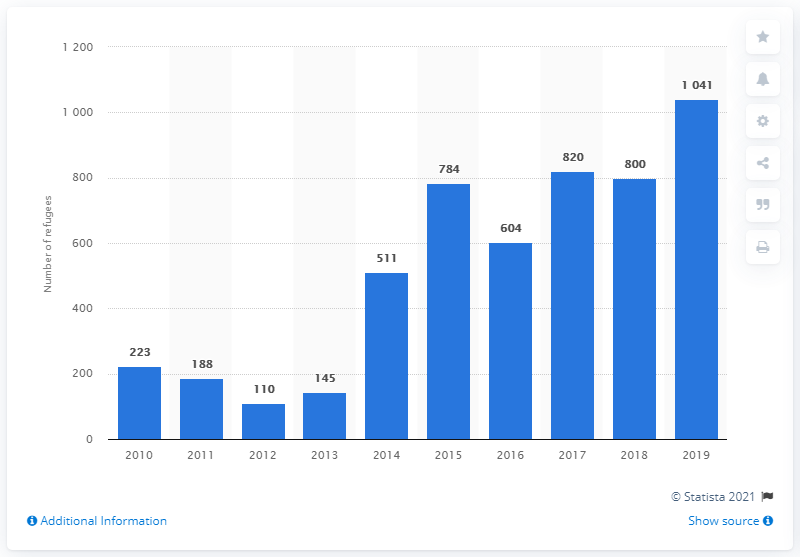Mention a couple of crucial points in this snapshot. In 2012, there were approximately 110 refugees living in Sri Lanka. 